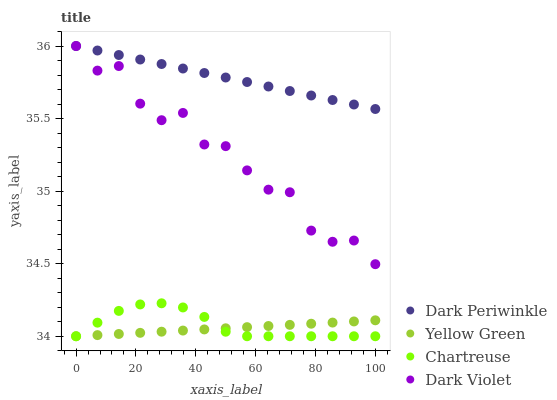Does Yellow Green have the minimum area under the curve?
Answer yes or no. Yes. Does Dark Periwinkle have the maximum area under the curve?
Answer yes or no. Yes. Does Dark Violet have the minimum area under the curve?
Answer yes or no. No. Does Dark Violet have the maximum area under the curve?
Answer yes or no. No. Is Yellow Green the smoothest?
Answer yes or no. Yes. Is Dark Violet the roughest?
Answer yes or no. Yes. Is Dark Periwinkle the smoothest?
Answer yes or no. No. Is Dark Periwinkle the roughest?
Answer yes or no. No. Does Chartreuse have the lowest value?
Answer yes or no. Yes. Does Dark Violet have the lowest value?
Answer yes or no. No. Does Dark Violet have the highest value?
Answer yes or no. Yes. Does Yellow Green have the highest value?
Answer yes or no. No. Is Chartreuse less than Dark Periwinkle?
Answer yes or no. Yes. Is Dark Periwinkle greater than Chartreuse?
Answer yes or no. Yes. Does Dark Violet intersect Dark Periwinkle?
Answer yes or no. Yes. Is Dark Violet less than Dark Periwinkle?
Answer yes or no. No. Is Dark Violet greater than Dark Periwinkle?
Answer yes or no. No. Does Chartreuse intersect Dark Periwinkle?
Answer yes or no. No. 